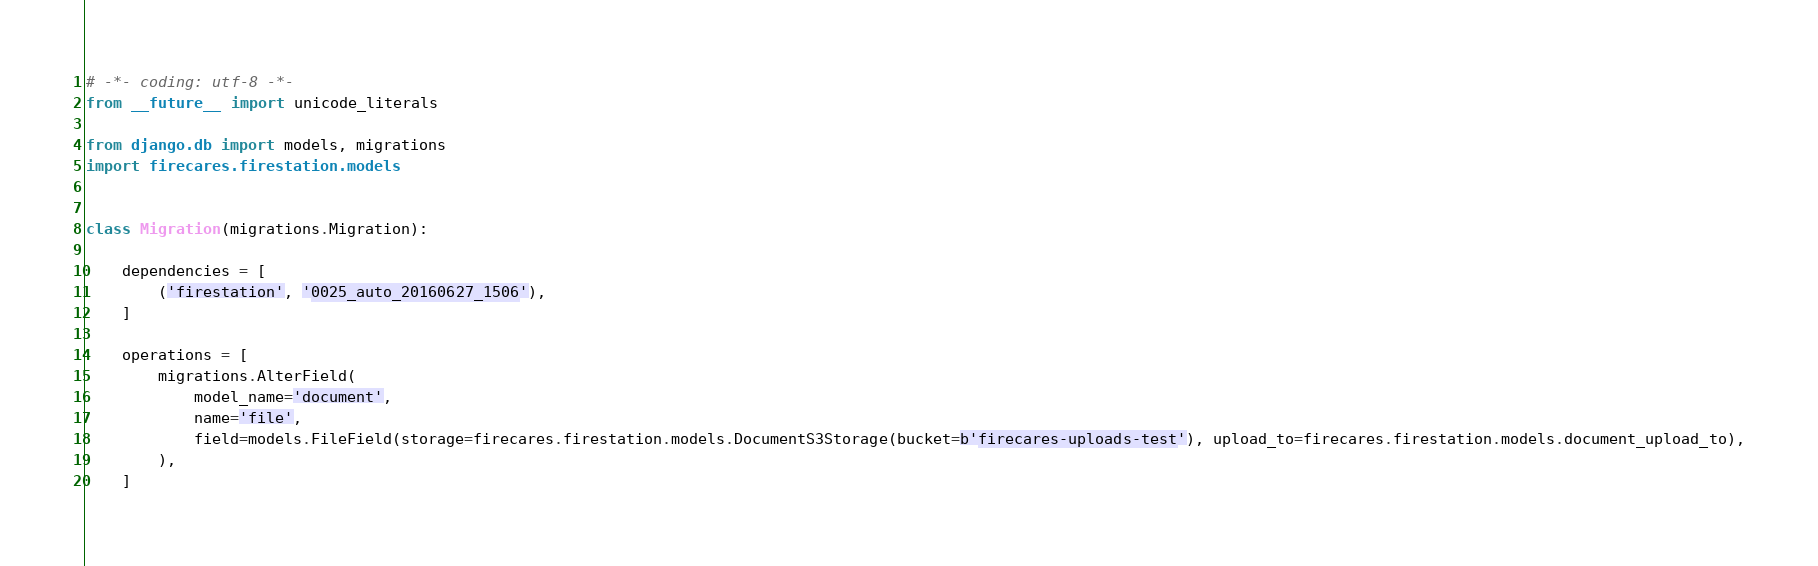Convert code to text. <code><loc_0><loc_0><loc_500><loc_500><_Python_># -*- coding: utf-8 -*-
from __future__ import unicode_literals

from django.db import models, migrations
import firecares.firestation.models


class Migration(migrations.Migration):

    dependencies = [
        ('firestation', '0025_auto_20160627_1506'),
    ]

    operations = [
        migrations.AlterField(
            model_name='document',
            name='file',
            field=models.FileField(storage=firecares.firestation.models.DocumentS3Storage(bucket=b'firecares-uploads-test'), upload_to=firecares.firestation.models.document_upload_to),
        ),
    ]
</code> 